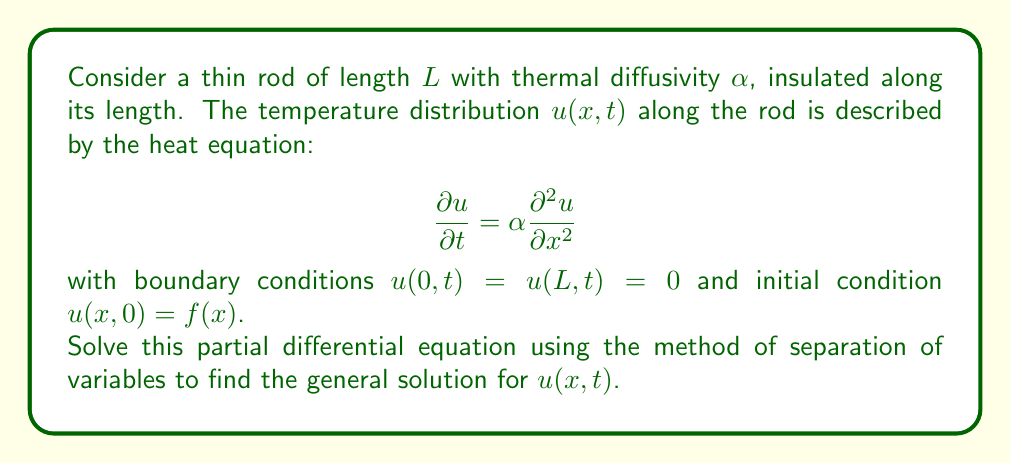Can you solve this math problem? To solve this problem using separation of variables, we follow these steps:

1) Assume the solution has the form $u(x,t) = X(x)T(t)$.

2) Substitute this into the PDE:

   $$X(x)\frac{dT}{dt} = \alpha T(t)\frac{d^2X}{dx^2}$$

3) Divide both sides by $\alpha X(x)T(t)$:

   $$\frac{1}{\alpha T}\frac{dT}{dt} = \frac{1}{X}\frac{d^2X}{dx^2}$$

4) Since the left side depends only on $t$ and the right side only on $x$, both must equal a constant. Call this constant $-\lambda^2$:

   $$\frac{1}{\alpha T}\frac{dT}{dt} = -\lambda^2 = \frac{1}{X}\frac{d^2X}{dx^2}$$

5) This gives us two ODEs:

   $$\frac{dT}{dt} + \alpha\lambda^2T = 0$$
   $$\frac{d^2X}{dx^2} + \lambda^2X = 0$$

6) The general solution for $T(t)$ is:

   $$T(t) = Ce^{-\alpha\lambda^2t}$$

7) For $X(x)$, we need to consider the boundary conditions. The general solution is:

   $$X(x) = A\sin(\lambda x) + B\cos(\lambda x)$$

   But $X(0) = 0$ implies $B = 0$, and $X(L) = 0$ implies $\sin(\lambda L) = 0$, so $\lambda_n = \frac{n\pi}{L}$ where $n = 1,2,3,...$

8) Therefore, the eigenfunction solutions are:

   $$X_n(x) = \sin(\frac{n\pi x}{L})$$

9) The general solution is a linear combination of these:

   $$u(x,t) = \sum_{n=1}^{\infty} c_n \sin(\frac{n\pi x}{L})e^{-\alpha(\frac{n\pi}{L})^2t}$$

10) To find $c_n$, we use the initial condition and the orthogonality of sines:

    $$c_n = \frac{2}{L}\int_0^L f(x)\sin(\frac{n\pi x}{L})dx$$

Thus, we have found the general solution to the PDE.
Answer: The general solution to the given partial differential equation is:

$$u(x,t) = \sum_{n=1}^{\infty} c_n \sin(\frac{n\pi x}{L})e^{-\alpha(\frac{n\pi}{L})^2t}$$

where $c_n = \frac{2}{L}\int_0^L f(x)\sin(\frac{n\pi x}{L})dx$, and $f(x)$ is the initial temperature distribution. 